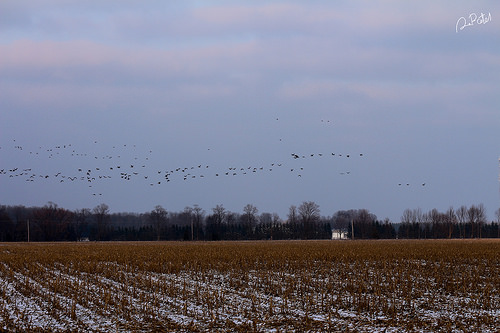<image>
Can you confirm if the birds is in the snow? No. The birds is not contained within the snow. These objects have a different spatial relationship. 